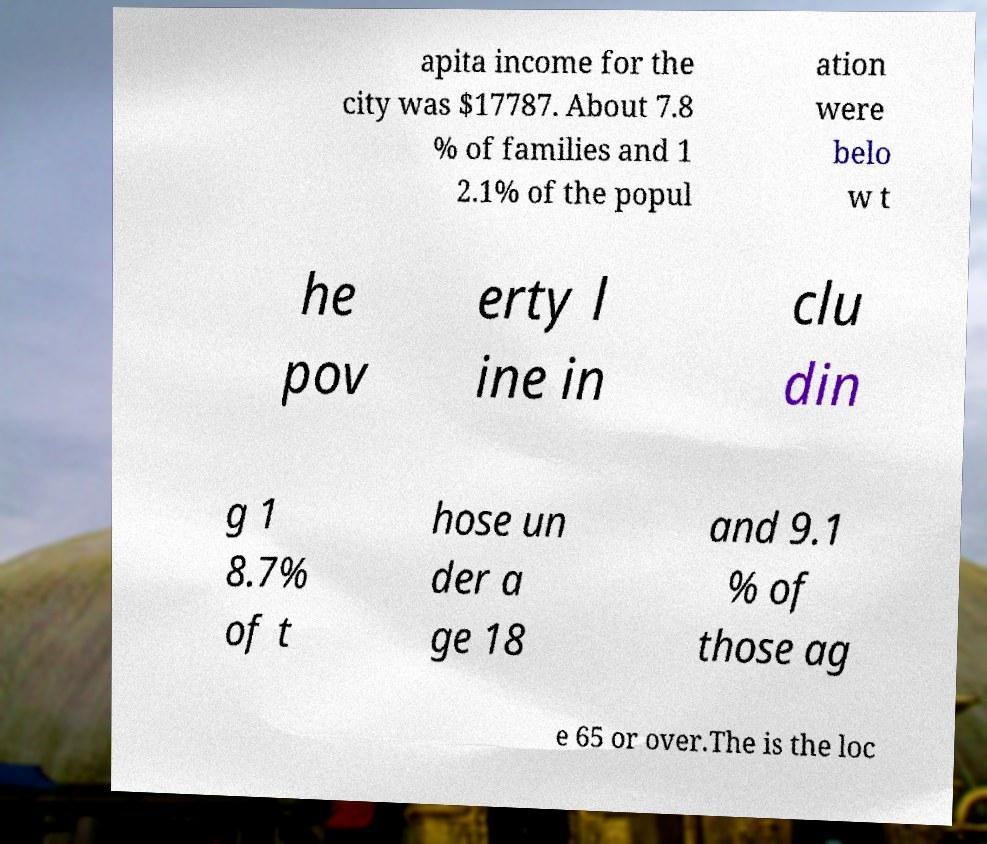For documentation purposes, I need the text within this image transcribed. Could you provide that? apita income for the city was $17787. About 7.8 % of families and 1 2.1% of the popul ation were belo w t he pov erty l ine in clu din g 1 8.7% of t hose un der a ge 18 and 9.1 % of those ag e 65 or over.The is the loc 